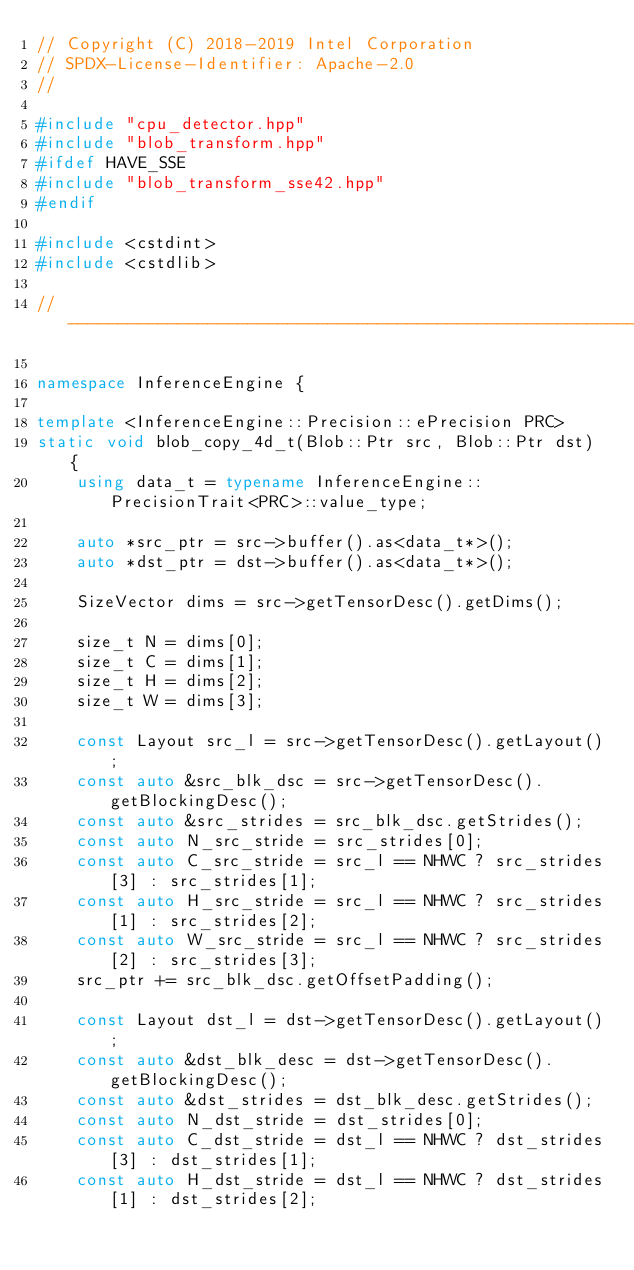Convert code to text. <code><loc_0><loc_0><loc_500><loc_500><_C++_>// Copyright (C) 2018-2019 Intel Corporation
// SPDX-License-Identifier: Apache-2.0
//

#include "cpu_detector.hpp"
#include "blob_transform.hpp"
#ifdef HAVE_SSE
#include "blob_transform_sse42.hpp"
#endif

#include <cstdint>
#include <cstdlib>

//----------------------------------------------------------------------

namespace InferenceEngine {

template <InferenceEngine::Precision::ePrecision PRC>
static void blob_copy_4d_t(Blob::Ptr src, Blob::Ptr dst) {
    using data_t = typename InferenceEngine::PrecisionTrait<PRC>::value_type;

    auto *src_ptr = src->buffer().as<data_t*>();
    auto *dst_ptr = dst->buffer().as<data_t*>();

    SizeVector dims = src->getTensorDesc().getDims();

    size_t N = dims[0];
    size_t C = dims[1];
    size_t H = dims[2];
    size_t W = dims[3];

    const Layout src_l = src->getTensorDesc().getLayout();
    const auto &src_blk_dsc = src->getTensorDesc().getBlockingDesc();
    const auto &src_strides = src_blk_dsc.getStrides();
    const auto N_src_stride = src_strides[0];
    const auto C_src_stride = src_l == NHWC ? src_strides[3] : src_strides[1];
    const auto H_src_stride = src_l == NHWC ? src_strides[1] : src_strides[2];
    const auto W_src_stride = src_l == NHWC ? src_strides[2] : src_strides[3];
    src_ptr += src_blk_dsc.getOffsetPadding();

    const Layout dst_l = dst->getTensorDesc().getLayout();
    const auto &dst_blk_desc = dst->getTensorDesc().getBlockingDesc();
    const auto &dst_strides = dst_blk_desc.getStrides();
    const auto N_dst_stride = dst_strides[0];
    const auto C_dst_stride = dst_l == NHWC ? dst_strides[3] : dst_strides[1];
    const auto H_dst_stride = dst_l == NHWC ? dst_strides[1] : dst_strides[2];</code> 